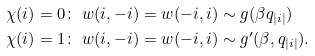Convert formula to latex. <formula><loc_0><loc_0><loc_500><loc_500>\chi ( i ) = 0 & \colon \ w ( i , - i ) = w ( - i , i ) \sim g ( \beta q _ { | i | } ) \\ \chi ( i ) = 1 & \colon \ w ( i , - i ) = w ( - i , i ) \sim g ^ { \prime } ( \beta , q _ { | i | } ) .</formula> 